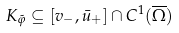<formula> <loc_0><loc_0><loc_500><loc_500>K _ { \tilde { \varphi } } \subseteq [ v _ { - } , \bar { u } _ { + } ] \cap C ^ { 1 } ( \overline { \Omega } )</formula> 